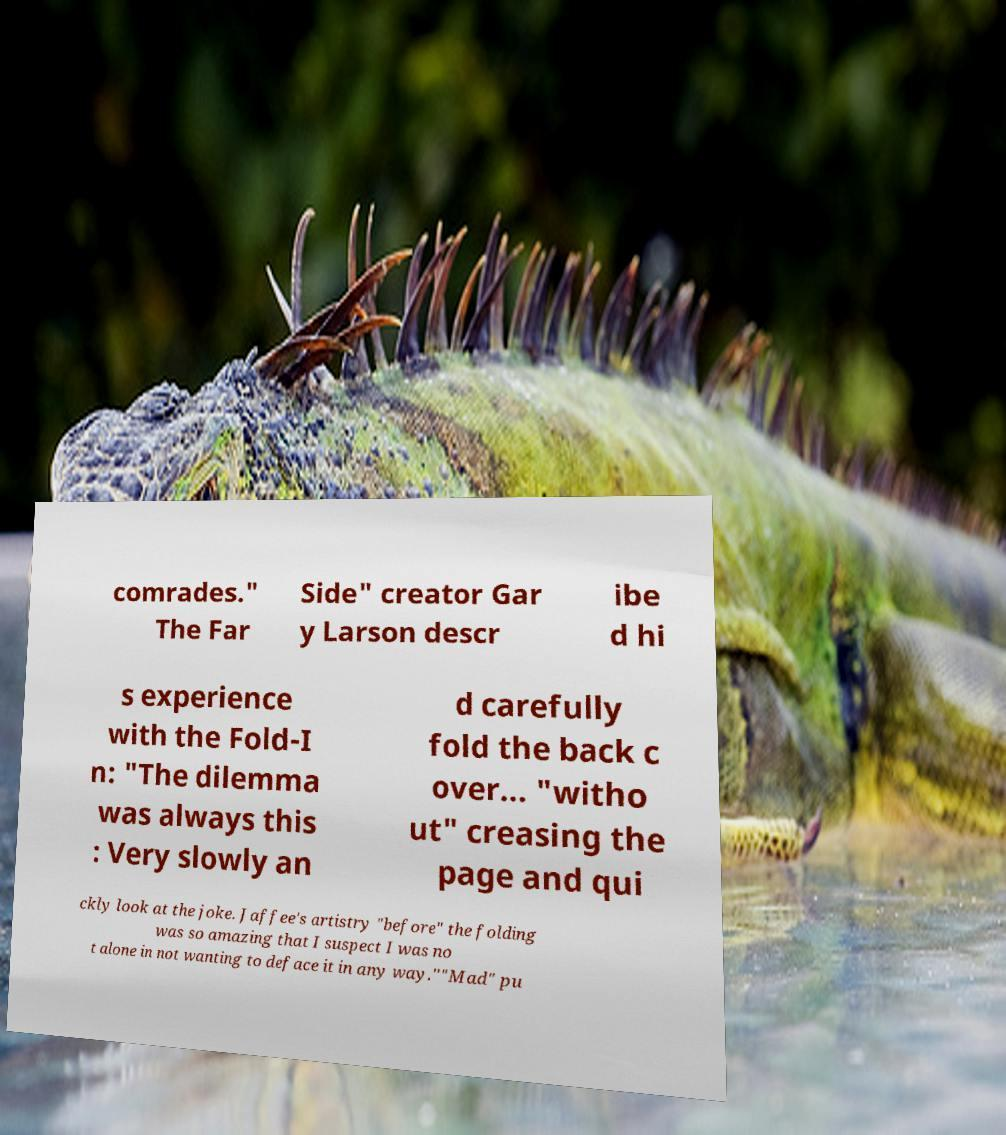Can you accurately transcribe the text from the provided image for me? comrades." The Far Side" creator Gar y Larson descr ibe d hi s experience with the Fold-I n: "The dilemma was always this : Very slowly an d carefully fold the back c over... "witho ut" creasing the page and qui ckly look at the joke. Jaffee's artistry "before" the folding was so amazing that I suspect I was no t alone in not wanting to deface it in any way.""Mad" pu 